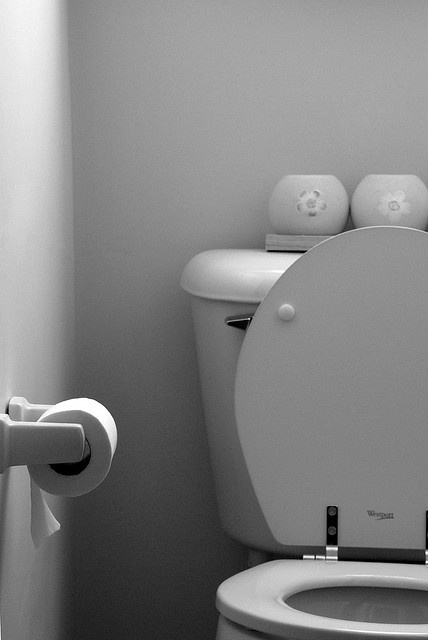Describe the objects in this image and their specific colors. I can see a toilet in white, gray, lightgray, and black tones in this image. 